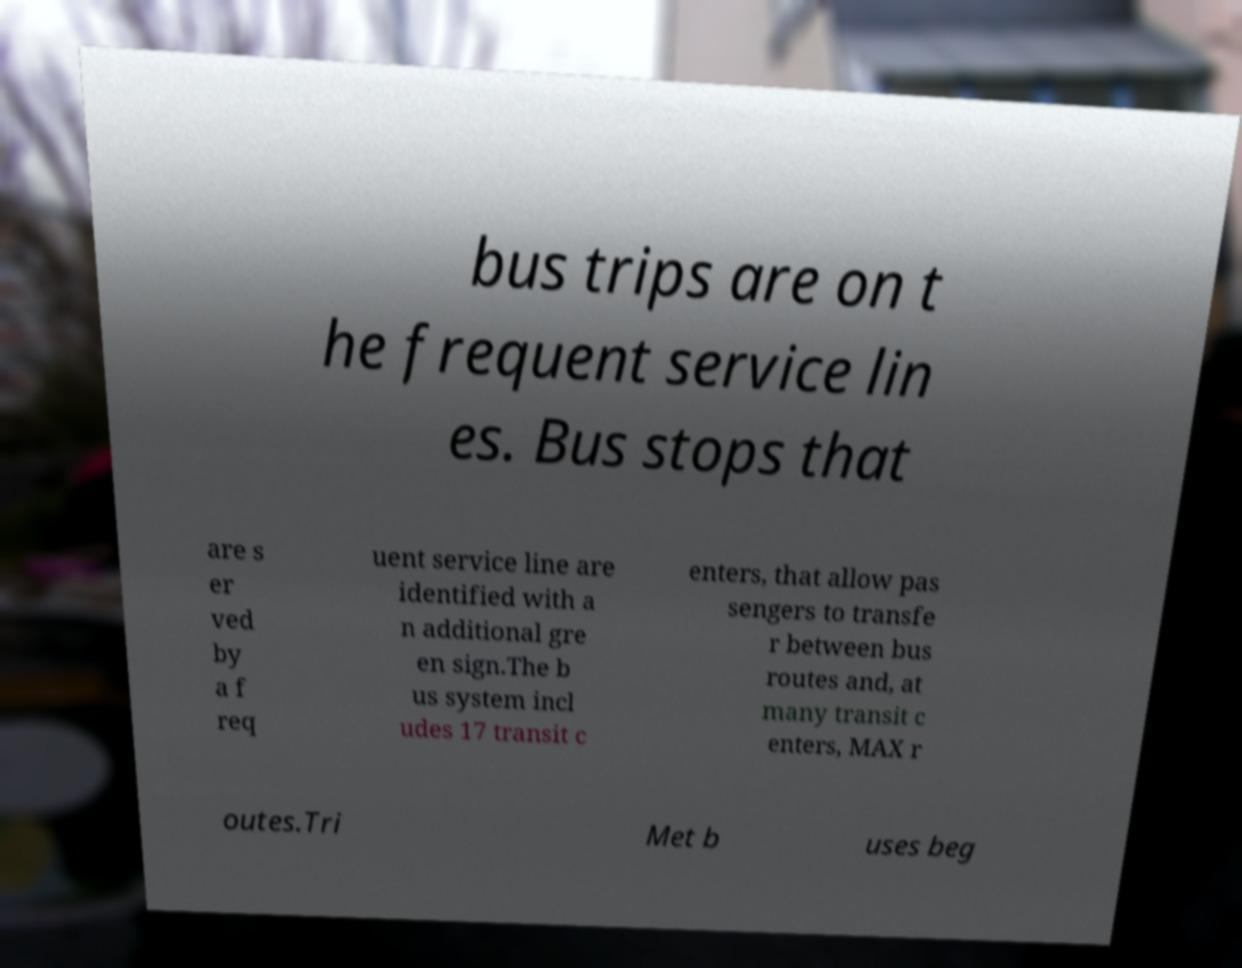Could you assist in decoding the text presented in this image and type it out clearly? bus trips are on t he frequent service lin es. Bus stops that are s er ved by a f req uent service line are identified with a n additional gre en sign.The b us system incl udes 17 transit c enters, that allow pas sengers to transfe r between bus routes and, at many transit c enters, MAX r outes.Tri Met b uses beg 